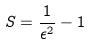Convert formula to latex. <formula><loc_0><loc_0><loc_500><loc_500>S = \frac { 1 } { \epsilon ^ { 2 } } - 1</formula> 